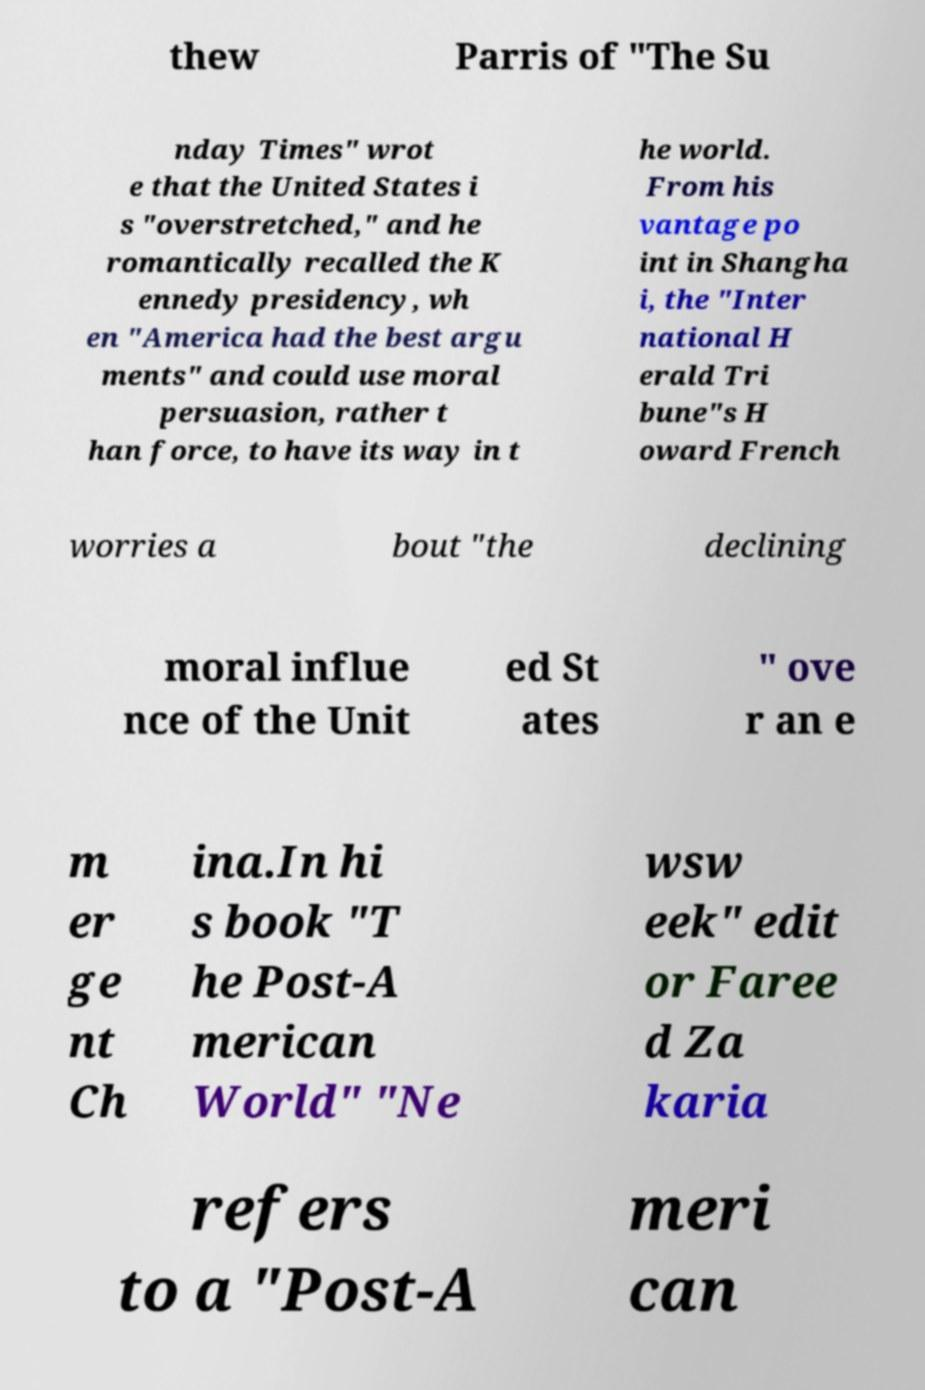There's text embedded in this image that I need extracted. Can you transcribe it verbatim? thew Parris of "The Su nday Times" wrot e that the United States i s "overstretched," and he romantically recalled the K ennedy presidency, wh en "America had the best argu ments" and could use moral persuasion, rather t han force, to have its way in t he world. From his vantage po int in Shangha i, the "Inter national H erald Tri bune"s H oward French worries a bout "the declining moral influe nce of the Unit ed St ates " ove r an e m er ge nt Ch ina.In hi s book "T he Post-A merican World" "Ne wsw eek" edit or Faree d Za karia refers to a "Post-A meri can 